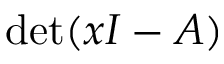Convert formula to latex. <formula><loc_0><loc_0><loc_500><loc_500>\det ( x I - A )</formula> 